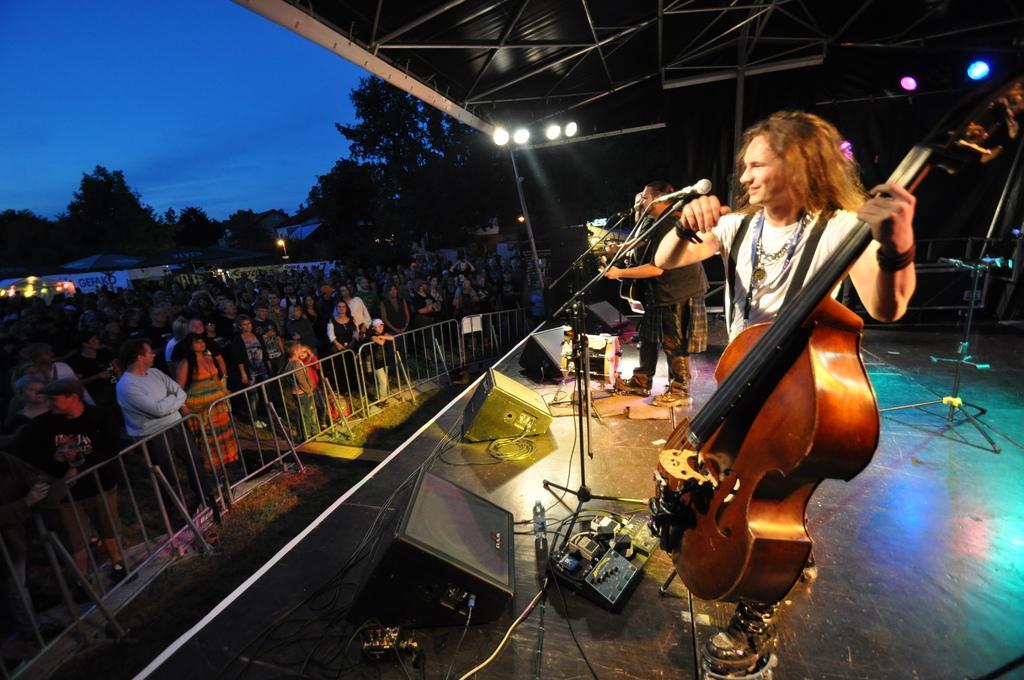Can you describe this image briefly? In this picture we can see two men on stage holding violin in his hand and singing on mic and in front of them we can see a crowd of people standing and looking at them beside fence and in background we can see trees, skylight, tent. 